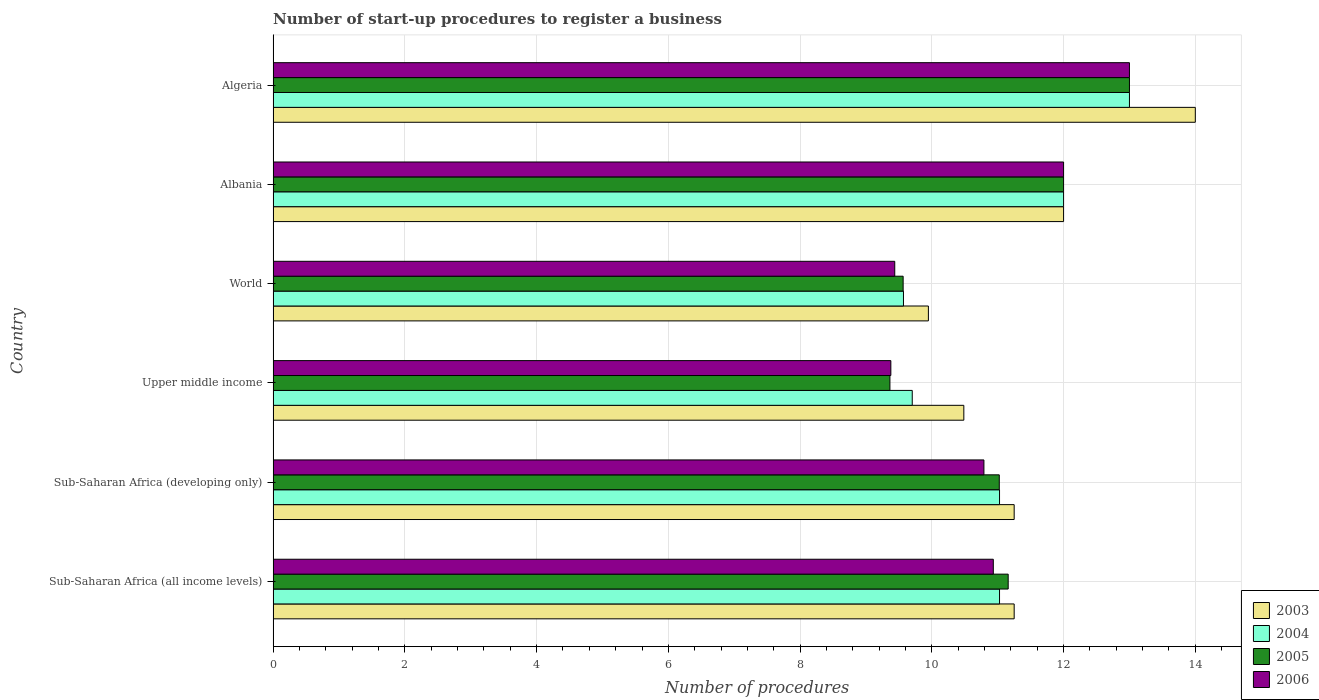How many different coloured bars are there?
Your answer should be compact. 4. Are the number of bars per tick equal to the number of legend labels?
Provide a short and direct response. Yes. How many bars are there on the 2nd tick from the top?
Your answer should be very brief. 4. What is the label of the 2nd group of bars from the top?
Ensure brevity in your answer.  Albania. In how many cases, is the number of bars for a given country not equal to the number of legend labels?
Make the answer very short. 0. What is the number of procedures required to register a business in 2005 in Upper middle income?
Offer a terse response. 9.36. Across all countries, what is the maximum number of procedures required to register a business in 2003?
Your answer should be very brief. 14. Across all countries, what is the minimum number of procedures required to register a business in 2005?
Provide a succinct answer. 9.36. In which country was the number of procedures required to register a business in 2004 maximum?
Keep it short and to the point. Algeria. In which country was the number of procedures required to register a business in 2004 minimum?
Ensure brevity in your answer.  World. What is the total number of procedures required to register a business in 2006 in the graph?
Provide a succinct answer. 65.54. What is the difference between the number of procedures required to register a business in 2004 in Albania and that in World?
Your response must be concise. 2.43. What is the difference between the number of procedures required to register a business in 2005 in Sub-Saharan Africa (all income levels) and the number of procedures required to register a business in 2006 in Algeria?
Keep it short and to the point. -1.84. What is the average number of procedures required to register a business in 2003 per country?
Your response must be concise. 11.49. What is the difference between the number of procedures required to register a business in 2003 and number of procedures required to register a business in 2005 in Sub-Saharan Africa (developing only)?
Ensure brevity in your answer.  0.23. What is the ratio of the number of procedures required to register a business in 2004 in Algeria to that in Sub-Saharan Africa (all income levels)?
Offer a very short reply. 1.18. Is the number of procedures required to register a business in 2006 in Sub-Saharan Africa (all income levels) less than that in Upper middle income?
Provide a short and direct response. No. What is the difference between the highest and the lowest number of procedures required to register a business in 2005?
Offer a very short reply. 3.64. In how many countries, is the number of procedures required to register a business in 2004 greater than the average number of procedures required to register a business in 2004 taken over all countries?
Provide a short and direct response. 2. Is the sum of the number of procedures required to register a business in 2005 in Albania and Upper middle income greater than the maximum number of procedures required to register a business in 2006 across all countries?
Your answer should be very brief. Yes. What does the 2nd bar from the bottom in Albania represents?
Your response must be concise. 2004. Are all the bars in the graph horizontal?
Ensure brevity in your answer.  Yes. How many countries are there in the graph?
Ensure brevity in your answer.  6. What is the difference between two consecutive major ticks on the X-axis?
Your response must be concise. 2. Are the values on the major ticks of X-axis written in scientific E-notation?
Give a very brief answer. No. Does the graph contain any zero values?
Your answer should be compact. No. What is the title of the graph?
Offer a very short reply. Number of start-up procedures to register a business. Does "1989" appear as one of the legend labels in the graph?
Offer a terse response. No. What is the label or title of the X-axis?
Offer a very short reply. Number of procedures. What is the label or title of the Y-axis?
Provide a short and direct response. Country. What is the Number of procedures in 2003 in Sub-Saharan Africa (all income levels)?
Give a very brief answer. 11.25. What is the Number of procedures of 2004 in Sub-Saharan Africa (all income levels)?
Your answer should be very brief. 11.03. What is the Number of procedures in 2005 in Sub-Saharan Africa (all income levels)?
Make the answer very short. 11.16. What is the Number of procedures in 2006 in Sub-Saharan Africa (all income levels)?
Offer a very short reply. 10.93. What is the Number of procedures of 2003 in Sub-Saharan Africa (developing only)?
Provide a short and direct response. 11.25. What is the Number of procedures in 2004 in Sub-Saharan Africa (developing only)?
Ensure brevity in your answer.  11.03. What is the Number of procedures in 2005 in Sub-Saharan Africa (developing only)?
Your response must be concise. 11.02. What is the Number of procedures in 2006 in Sub-Saharan Africa (developing only)?
Your response must be concise. 10.79. What is the Number of procedures in 2003 in Upper middle income?
Your answer should be compact. 10.49. What is the Number of procedures of 2004 in Upper middle income?
Ensure brevity in your answer.  9.7. What is the Number of procedures of 2005 in Upper middle income?
Your response must be concise. 9.36. What is the Number of procedures of 2006 in Upper middle income?
Offer a terse response. 9.38. What is the Number of procedures in 2003 in World?
Offer a terse response. 9.95. What is the Number of procedures of 2004 in World?
Ensure brevity in your answer.  9.57. What is the Number of procedures in 2005 in World?
Your answer should be very brief. 9.56. What is the Number of procedures in 2006 in World?
Offer a very short reply. 9.44. What is the Number of procedures in 2003 in Albania?
Offer a terse response. 12. What is the Number of procedures of 2004 in Albania?
Your response must be concise. 12. What is the Number of procedures in 2006 in Albania?
Provide a short and direct response. 12. Across all countries, what is the maximum Number of procedures of 2003?
Offer a very short reply. 14. Across all countries, what is the maximum Number of procedures of 2006?
Provide a short and direct response. 13. Across all countries, what is the minimum Number of procedures of 2003?
Your answer should be very brief. 9.95. Across all countries, what is the minimum Number of procedures in 2004?
Offer a terse response. 9.57. Across all countries, what is the minimum Number of procedures in 2005?
Your response must be concise. 9.36. Across all countries, what is the minimum Number of procedures of 2006?
Your answer should be compact. 9.38. What is the total Number of procedures in 2003 in the graph?
Your answer should be compact. 68.93. What is the total Number of procedures in 2004 in the graph?
Give a very brief answer. 66.33. What is the total Number of procedures in 2005 in the graph?
Offer a very short reply. 66.11. What is the total Number of procedures in 2006 in the graph?
Make the answer very short. 65.54. What is the difference between the Number of procedures of 2005 in Sub-Saharan Africa (all income levels) and that in Sub-Saharan Africa (developing only)?
Your response must be concise. 0.14. What is the difference between the Number of procedures of 2006 in Sub-Saharan Africa (all income levels) and that in Sub-Saharan Africa (developing only)?
Your response must be concise. 0.14. What is the difference between the Number of procedures of 2003 in Sub-Saharan Africa (all income levels) and that in Upper middle income?
Provide a succinct answer. 0.76. What is the difference between the Number of procedures in 2004 in Sub-Saharan Africa (all income levels) and that in Upper middle income?
Offer a terse response. 1.33. What is the difference between the Number of procedures in 2005 in Sub-Saharan Africa (all income levels) and that in Upper middle income?
Provide a short and direct response. 1.8. What is the difference between the Number of procedures of 2006 in Sub-Saharan Africa (all income levels) and that in Upper middle income?
Offer a very short reply. 1.56. What is the difference between the Number of procedures of 2003 in Sub-Saharan Africa (all income levels) and that in World?
Ensure brevity in your answer.  1.3. What is the difference between the Number of procedures in 2004 in Sub-Saharan Africa (all income levels) and that in World?
Give a very brief answer. 1.46. What is the difference between the Number of procedures in 2005 in Sub-Saharan Africa (all income levels) and that in World?
Make the answer very short. 1.59. What is the difference between the Number of procedures in 2006 in Sub-Saharan Africa (all income levels) and that in World?
Provide a short and direct response. 1.5. What is the difference between the Number of procedures of 2003 in Sub-Saharan Africa (all income levels) and that in Albania?
Give a very brief answer. -0.75. What is the difference between the Number of procedures of 2004 in Sub-Saharan Africa (all income levels) and that in Albania?
Offer a very short reply. -0.97. What is the difference between the Number of procedures of 2005 in Sub-Saharan Africa (all income levels) and that in Albania?
Offer a terse response. -0.84. What is the difference between the Number of procedures of 2006 in Sub-Saharan Africa (all income levels) and that in Albania?
Offer a very short reply. -1.07. What is the difference between the Number of procedures in 2003 in Sub-Saharan Africa (all income levels) and that in Algeria?
Offer a very short reply. -2.75. What is the difference between the Number of procedures in 2004 in Sub-Saharan Africa (all income levels) and that in Algeria?
Keep it short and to the point. -1.97. What is the difference between the Number of procedures in 2005 in Sub-Saharan Africa (all income levels) and that in Algeria?
Provide a short and direct response. -1.84. What is the difference between the Number of procedures of 2006 in Sub-Saharan Africa (all income levels) and that in Algeria?
Offer a very short reply. -2.07. What is the difference between the Number of procedures in 2003 in Sub-Saharan Africa (developing only) and that in Upper middle income?
Keep it short and to the point. 0.76. What is the difference between the Number of procedures in 2004 in Sub-Saharan Africa (developing only) and that in Upper middle income?
Your response must be concise. 1.33. What is the difference between the Number of procedures of 2005 in Sub-Saharan Africa (developing only) and that in Upper middle income?
Offer a very short reply. 1.66. What is the difference between the Number of procedures of 2006 in Sub-Saharan Africa (developing only) and that in Upper middle income?
Your answer should be compact. 1.41. What is the difference between the Number of procedures in 2003 in Sub-Saharan Africa (developing only) and that in World?
Provide a succinct answer. 1.3. What is the difference between the Number of procedures in 2004 in Sub-Saharan Africa (developing only) and that in World?
Keep it short and to the point. 1.46. What is the difference between the Number of procedures of 2005 in Sub-Saharan Africa (developing only) and that in World?
Your answer should be very brief. 1.46. What is the difference between the Number of procedures in 2006 in Sub-Saharan Africa (developing only) and that in World?
Offer a very short reply. 1.35. What is the difference between the Number of procedures in 2003 in Sub-Saharan Africa (developing only) and that in Albania?
Provide a short and direct response. -0.75. What is the difference between the Number of procedures in 2004 in Sub-Saharan Africa (developing only) and that in Albania?
Provide a succinct answer. -0.97. What is the difference between the Number of procedures in 2005 in Sub-Saharan Africa (developing only) and that in Albania?
Your response must be concise. -0.98. What is the difference between the Number of procedures in 2006 in Sub-Saharan Africa (developing only) and that in Albania?
Keep it short and to the point. -1.21. What is the difference between the Number of procedures in 2003 in Sub-Saharan Africa (developing only) and that in Algeria?
Your response must be concise. -2.75. What is the difference between the Number of procedures in 2004 in Sub-Saharan Africa (developing only) and that in Algeria?
Ensure brevity in your answer.  -1.97. What is the difference between the Number of procedures in 2005 in Sub-Saharan Africa (developing only) and that in Algeria?
Your response must be concise. -1.98. What is the difference between the Number of procedures of 2006 in Sub-Saharan Africa (developing only) and that in Algeria?
Your answer should be compact. -2.21. What is the difference between the Number of procedures of 2003 in Upper middle income and that in World?
Keep it short and to the point. 0.54. What is the difference between the Number of procedures in 2004 in Upper middle income and that in World?
Keep it short and to the point. 0.13. What is the difference between the Number of procedures of 2005 in Upper middle income and that in World?
Ensure brevity in your answer.  -0.2. What is the difference between the Number of procedures in 2006 in Upper middle income and that in World?
Your answer should be very brief. -0.06. What is the difference between the Number of procedures in 2003 in Upper middle income and that in Albania?
Make the answer very short. -1.51. What is the difference between the Number of procedures in 2004 in Upper middle income and that in Albania?
Your response must be concise. -2.3. What is the difference between the Number of procedures in 2005 in Upper middle income and that in Albania?
Provide a succinct answer. -2.64. What is the difference between the Number of procedures of 2006 in Upper middle income and that in Albania?
Provide a short and direct response. -2.62. What is the difference between the Number of procedures in 2003 in Upper middle income and that in Algeria?
Provide a succinct answer. -3.51. What is the difference between the Number of procedures of 2004 in Upper middle income and that in Algeria?
Provide a short and direct response. -3.3. What is the difference between the Number of procedures of 2005 in Upper middle income and that in Algeria?
Offer a very short reply. -3.64. What is the difference between the Number of procedures of 2006 in Upper middle income and that in Algeria?
Make the answer very short. -3.62. What is the difference between the Number of procedures in 2003 in World and that in Albania?
Offer a terse response. -2.05. What is the difference between the Number of procedures in 2004 in World and that in Albania?
Keep it short and to the point. -2.43. What is the difference between the Number of procedures in 2005 in World and that in Albania?
Provide a short and direct response. -2.44. What is the difference between the Number of procedures of 2006 in World and that in Albania?
Your response must be concise. -2.56. What is the difference between the Number of procedures in 2003 in World and that in Algeria?
Offer a terse response. -4.05. What is the difference between the Number of procedures of 2004 in World and that in Algeria?
Your response must be concise. -3.43. What is the difference between the Number of procedures of 2005 in World and that in Algeria?
Give a very brief answer. -3.44. What is the difference between the Number of procedures in 2006 in World and that in Algeria?
Offer a terse response. -3.56. What is the difference between the Number of procedures of 2005 in Albania and that in Algeria?
Give a very brief answer. -1. What is the difference between the Number of procedures in 2003 in Sub-Saharan Africa (all income levels) and the Number of procedures in 2004 in Sub-Saharan Africa (developing only)?
Offer a terse response. 0.22. What is the difference between the Number of procedures in 2003 in Sub-Saharan Africa (all income levels) and the Number of procedures in 2005 in Sub-Saharan Africa (developing only)?
Ensure brevity in your answer.  0.23. What is the difference between the Number of procedures in 2003 in Sub-Saharan Africa (all income levels) and the Number of procedures in 2006 in Sub-Saharan Africa (developing only)?
Keep it short and to the point. 0.46. What is the difference between the Number of procedures of 2004 in Sub-Saharan Africa (all income levels) and the Number of procedures of 2005 in Sub-Saharan Africa (developing only)?
Provide a succinct answer. 0. What is the difference between the Number of procedures of 2004 in Sub-Saharan Africa (all income levels) and the Number of procedures of 2006 in Sub-Saharan Africa (developing only)?
Give a very brief answer. 0.24. What is the difference between the Number of procedures in 2005 in Sub-Saharan Africa (all income levels) and the Number of procedures in 2006 in Sub-Saharan Africa (developing only)?
Provide a short and direct response. 0.37. What is the difference between the Number of procedures of 2003 in Sub-Saharan Africa (all income levels) and the Number of procedures of 2004 in Upper middle income?
Offer a very short reply. 1.55. What is the difference between the Number of procedures of 2003 in Sub-Saharan Africa (all income levels) and the Number of procedures of 2005 in Upper middle income?
Provide a short and direct response. 1.89. What is the difference between the Number of procedures in 2003 in Sub-Saharan Africa (all income levels) and the Number of procedures in 2006 in Upper middle income?
Provide a short and direct response. 1.87. What is the difference between the Number of procedures in 2004 in Sub-Saharan Africa (all income levels) and the Number of procedures in 2005 in Upper middle income?
Offer a terse response. 1.66. What is the difference between the Number of procedures in 2004 in Sub-Saharan Africa (all income levels) and the Number of procedures in 2006 in Upper middle income?
Provide a short and direct response. 1.65. What is the difference between the Number of procedures of 2005 in Sub-Saharan Africa (all income levels) and the Number of procedures of 2006 in Upper middle income?
Give a very brief answer. 1.78. What is the difference between the Number of procedures in 2003 in Sub-Saharan Africa (all income levels) and the Number of procedures in 2004 in World?
Offer a very short reply. 1.68. What is the difference between the Number of procedures in 2003 in Sub-Saharan Africa (all income levels) and the Number of procedures in 2005 in World?
Give a very brief answer. 1.69. What is the difference between the Number of procedures in 2003 in Sub-Saharan Africa (all income levels) and the Number of procedures in 2006 in World?
Keep it short and to the point. 1.81. What is the difference between the Number of procedures in 2004 in Sub-Saharan Africa (all income levels) and the Number of procedures in 2005 in World?
Provide a succinct answer. 1.46. What is the difference between the Number of procedures in 2004 in Sub-Saharan Africa (all income levels) and the Number of procedures in 2006 in World?
Your answer should be compact. 1.59. What is the difference between the Number of procedures of 2005 in Sub-Saharan Africa (all income levels) and the Number of procedures of 2006 in World?
Give a very brief answer. 1.72. What is the difference between the Number of procedures in 2003 in Sub-Saharan Africa (all income levels) and the Number of procedures in 2004 in Albania?
Make the answer very short. -0.75. What is the difference between the Number of procedures of 2003 in Sub-Saharan Africa (all income levels) and the Number of procedures of 2005 in Albania?
Provide a succinct answer. -0.75. What is the difference between the Number of procedures in 2003 in Sub-Saharan Africa (all income levels) and the Number of procedures in 2006 in Albania?
Your answer should be compact. -0.75. What is the difference between the Number of procedures in 2004 in Sub-Saharan Africa (all income levels) and the Number of procedures in 2005 in Albania?
Your response must be concise. -0.97. What is the difference between the Number of procedures of 2004 in Sub-Saharan Africa (all income levels) and the Number of procedures of 2006 in Albania?
Give a very brief answer. -0.97. What is the difference between the Number of procedures of 2005 in Sub-Saharan Africa (all income levels) and the Number of procedures of 2006 in Albania?
Provide a succinct answer. -0.84. What is the difference between the Number of procedures of 2003 in Sub-Saharan Africa (all income levels) and the Number of procedures of 2004 in Algeria?
Offer a very short reply. -1.75. What is the difference between the Number of procedures in 2003 in Sub-Saharan Africa (all income levels) and the Number of procedures in 2005 in Algeria?
Provide a succinct answer. -1.75. What is the difference between the Number of procedures of 2003 in Sub-Saharan Africa (all income levels) and the Number of procedures of 2006 in Algeria?
Ensure brevity in your answer.  -1.75. What is the difference between the Number of procedures of 2004 in Sub-Saharan Africa (all income levels) and the Number of procedures of 2005 in Algeria?
Give a very brief answer. -1.97. What is the difference between the Number of procedures in 2004 in Sub-Saharan Africa (all income levels) and the Number of procedures in 2006 in Algeria?
Make the answer very short. -1.97. What is the difference between the Number of procedures of 2005 in Sub-Saharan Africa (all income levels) and the Number of procedures of 2006 in Algeria?
Your answer should be very brief. -1.84. What is the difference between the Number of procedures in 2003 in Sub-Saharan Africa (developing only) and the Number of procedures in 2004 in Upper middle income?
Offer a terse response. 1.55. What is the difference between the Number of procedures in 2003 in Sub-Saharan Africa (developing only) and the Number of procedures in 2005 in Upper middle income?
Offer a very short reply. 1.89. What is the difference between the Number of procedures of 2003 in Sub-Saharan Africa (developing only) and the Number of procedures of 2006 in Upper middle income?
Provide a succinct answer. 1.87. What is the difference between the Number of procedures of 2004 in Sub-Saharan Africa (developing only) and the Number of procedures of 2005 in Upper middle income?
Offer a very short reply. 1.66. What is the difference between the Number of procedures in 2004 in Sub-Saharan Africa (developing only) and the Number of procedures in 2006 in Upper middle income?
Your response must be concise. 1.65. What is the difference between the Number of procedures in 2005 in Sub-Saharan Africa (developing only) and the Number of procedures in 2006 in Upper middle income?
Ensure brevity in your answer.  1.65. What is the difference between the Number of procedures of 2003 in Sub-Saharan Africa (developing only) and the Number of procedures of 2004 in World?
Ensure brevity in your answer.  1.68. What is the difference between the Number of procedures of 2003 in Sub-Saharan Africa (developing only) and the Number of procedures of 2005 in World?
Your answer should be very brief. 1.69. What is the difference between the Number of procedures in 2003 in Sub-Saharan Africa (developing only) and the Number of procedures in 2006 in World?
Offer a very short reply. 1.81. What is the difference between the Number of procedures in 2004 in Sub-Saharan Africa (developing only) and the Number of procedures in 2005 in World?
Keep it short and to the point. 1.46. What is the difference between the Number of procedures of 2004 in Sub-Saharan Africa (developing only) and the Number of procedures of 2006 in World?
Your response must be concise. 1.59. What is the difference between the Number of procedures of 2005 in Sub-Saharan Africa (developing only) and the Number of procedures of 2006 in World?
Provide a succinct answer. 1.59. What is the difference between the Number of procedures of 2003 in Sub-Saharan Africa (developing only) and the Number of procedures of 2004 in Albania?
Provide a succinct answer. -0.75. What is the difference between the Number of procedures in 2003 in Sub-Saharan Africa (developing only) and the Number of procedures in 2005 in Albania?
Your answer should be very brief. -0.75. What is the difference between the Number of procedures in 2003 in Sub-Saharan Africa (developing only) and the Number of procedures in 2006 in Albania?
Your answer should be compact. -0.75. What is the difference between the Number of procedures in 2004 in Sub-Saharan Africa (developing only) and the Number of procedures in 2005 in Albania?
Offer a very short reply. -0.97. What is the difference between the Number of procedures in 2004 in Sub-Saharan Africa (developing only) and the Number of procedures in 2006 in Albania?
Your answer should be compact. -0.97. What is the difference between the Number of procedures of 2005 in Sub-Saharan Africa (developing only) and the Number of procedures of 2006 in Albania?
Keep it short and to the point. -0.98. What is the difference between the Number of procedures of 2003 in Sub-Saharan Africa (developing only) and the Number of procedures of 2004 in Algeria?
Provide a succinct answer. -1.75. What is the difference between the Number of procedures in 2003 in Sub-Saharan Africa (developing only) and the Number of procedures in 2005 in Algeria?
Keep it short and to the point. -1.75. What is the difference between the Number of procedures of 2003 in Sub-Saharan Africa (developing only) and the Number of procedures of 2006 in Algeria?
Your answer should be very brief. -1.75. What is the difference between the Number of procedures in 2004 in Sub-Saharan Africa (developing only) and the Number of procedures in 2005 in Algeria?
Your answer should be very brief. -1.97. What is the difference between the Number of procedures in 2004 in Sub-Saharan Africa (developing only) and the Number of procedures in 2006 in Algeria?
Offer a terse response. -1.97. What is the difference between the Number of procedures in 2005 in Sub-Saharan Africa (developing only) and the Number of procedures in 2006 in Algeria?
Offer a very short reply. -1.98. What is the difference between the Number of procedures of 2003 in Upper middle income and the Number of procedures of 2004 in World?
Your response must be concise. 0.92. What is the difference between the Number of procedures of 2003 in Upper middle income and the Number of procedures of 2005 in World?
Your response must be concise. 0.92. What is the difference between the Number of procedures in 2003 in Upper middle income and the Number of procedures in 2006 in World?
Keep it short and to the point. 1.05. What is the difference between the Number of procedures of 2004 in Upper middle income and the Number of procedures of 2005 in World?
Make the answer very short. 0.14. What is the difference between the Number of procedures in 2004 in Upper middle income and the Number of procedures in 2006 in World?
Offer a very short reply. 0.27. What is the difference between the Number of procedures of 2005 in Upper middle income and the Number of procedures of 2006 in World?
Provide a short and direct response. -0.07. What is the difference between the Number of procedures of 2003 in Upper middle income and the Number of procedures of 2004 in Albania?
Make the answer very short. -1.51. What is the difference between the Number of procedures in 2003 in Upper middle income and the Number of procedures in 2005 in Albania?
Your response must be concise. -1.51. What is the difference between the Number of procedures of 2003 in Upper middle income and the Number of procedures of 2006 in Albania?
Offer a very short reply. -1.51. What is the difference between the Number of procedures in 2004 in Upper middle income and the Number of procedures in 2005 in Albania?
Your answer should be compact. -2.3. What is the difference between the Number of procedures of 2004 in Upper middle income and the Number of procedures of 2006 in Albania?
Your answer should be very brief. -2.3. What is the difference between the Number of procedures in 2005 in Upper middle income and the Number of procedures in 2006 in Albania?
Your answer should be compact. -2.64. What is the difference between the Number of procedures in 2003 in Upper middle income and the Number of procedures in 2004 in Algeria?
Provide a succinct answer. -2.51. What is the difference between the Number of procedures of 2003 in Upper middle income and the Number of procedures of 2005 in Algeria?
Keep it short and to the point. -2.51. What is the difference between the Number of procedures in 2003 in Upper middle income and the Number of procedures in 2006 in Algeria?
Provide a short and direct response. -2.51. What is the difference between the Number of procedures in 2004 in Upper middle income and the Number of procedures in 2005 in Algeria?
Your response must be concise. -3.3. What is the difference between the Number of procedures of 2004 in Upper middle income and the Number of procedures of 2006 in Algeria?
Provide a short and direct response. -3.3. What is the difference between the Number of procedures of 2005 in Upper middle income and the Number of procedures of 2006 in Algeria?
Provide a short and direct response. -3.64. What is the difference between the Number of procedures in 2003 in World and the Number of procedures in 2004 in Albania?
Make the answer very short. -2.05. What is the difference between the Number of procedures in 2003 in World and the Number of procedures in 2005 in Albania?
Your response must be concise. -2.05. What is the difference between the Number of procedures of 2003 in World and the Number of procedures of 2006 in Albania?
Your answer should be compact. -2.05. What is the difference between the Number of procedures in 2004 in World and the Number of procedures in 2005 in Albania?
Your answer should be compact. -2.43. What is the difference between the Number of procedures of 2004 in World and the Number of procedures of 2006 in Albania?
Offer a terse response. -2.43. What is the difference between the Number of procedures of 2005 in World and the Number of procedures of 2006 in Albania?
Provide a succinct answer. -2.44. What is the difference between the Number of procedures in 2003 in World and the Number of procedures in 2004 in Algeria?
Your response must be concise. -3.05. What is the difference between the Number of procedures of 2003 in World and the Number of procedures of 2005 in Algeria?
Your answer should be compact. -3.05. What is the difference between the Number of procedures of 2003 in World and the Number of procedures of 2006 in Algeria?
Offer a terse response. -3.05. What is the difference between the Number of procedures of 2004 in World and the Number of procedures of 2005 in Algeria?
Offer a very short reply. -3.43. What is the difference between the Number of procedures in 2004 in World and the Number of procedures in 2006 in Algeria?
Give a very brief answer. -3.43. What is the difference between the Number of procedures in 2005 in World and the Number of procedures in 2006 in Algeria?
Keep it short and to the point. -3.44. What is the difference between the Number of procedures in 2003 in Albania and the Number of procedures in 2004 in Algeria?
Make the answer very short. -1. What is the difference between the Number of procedures in 2003 in Albania and the Number of procedures in 2006 in Algeria?
Provide a succinct answer. -1. What is the difference between the Number of procedures of 2005 in Albania and the Number of procedures of 2006 in Algeria?
Ensure brevity in your answer.  -1. What is the average Number of procedures of 2003 per country?
Make the answer very short. 11.49. What is the average Number of procedures of 2004 per country?
Provide a succinct answer. 11.05. What is the average Number of procedures of 2005 per country?
Ensure brevity in your answer.  11.02. What is the average Number of procedures in 2006 per country?
Give a very brief answer. 10.92. What is the difference between the Number of procedures of 2003 and Number of procedures of 2004 in Sub-Saharan Africa (all income levels)?
Provide a short and direct response. 0.22. What is the difference between the Number of procedures in 2003 and Number of procedures in 2005 in Sub-Saharan Africa (all income levels)?
Provide a short and direct response. 0.09. What is the difference between the Number of procedures in 2003 and Number of procedures in 2006 in Sub-Saharan Africa (all income levels)?
Provide a succinct answer. 0.32. What is the difference between the Number of procedures of 2004 and Number of procedures of 2005 in Sub-Saharan Africa (all income levels)?
Make the answer very short. -0.13. What is the difference between the Number of procedures of 2004 and Number of procedures of 2006 in Sub-Saharan Africa (all income levels)?
Make the answer very short. 0.09. What is the difference between the Number of procedures of 2005 and Number of procedures of 2006 in Sub-Saharan Africa (all income levels)?
Give a very brief answer. 0.23. What is the difference between the Number of procedures of 2003 and Number of procedures of 2004 in Sub-Saharan Africa (developing only)?
Provide a short and direct response. 0.22. What is the difference between the Number of procedures of 2003 and Number of procedures of 2005 in Sub-Saharan Africa (developing only)?
Your response must be concise. 0.23. What is the difference between the Number of procedures of 2003 and Number of procedures of 2006 in Sub-Saharan Africa (developing only)?
Give a very brief answer. 0.46. What is the difference between the Number of procedures of 2004 and Number of procedures of 2005 in Sub-Saharan Africa (developing only)?
Keep it short and to the point. 0. What is the difference between the Number of procedures of 2004 and Number of procedures of 2006 in Sub-Saharan Africa (developing only)?
Provide a short and direct response. 0.24. What is the difference between the Number of procedures of 2005 and Number of procedures of 2006 in Sub-Saharan Africa (developing only)?
Provide a short and direct response. 0.23. What is the difference between the Number of procedures of 2003 and Number of procedures of 2004 in Upper middle income?
Your response must be concise. 0.78. What is the difference between the Number of procedures in 2003 and Number of procedures in 2005 in Upper middle income?
Offer a very short reply. 1.12. What is the difference between the Number of procedures in 2003 and Number of procedures in 2006 in Upper middle income?
Make the answer very short. 1.11. What is the difference between the Number of procedures of 2004 and Number of procedures of 2005 in Upper middle income?
Your response must be concise. 0.34. What is the difference between the Number of procedures in 2004 and Number of procedures in 2006 in Upper middle income?
Keep it short and to the point. 0.32. What is the difference between the Number of procedures of 2005 and Number of procedures of 2006 in Upper middle income?
Your response must be concise. -0.01. What is the difference between the Number of procedures in 2003 and Number of procedures in 2004 in World?
Your response must be concise. 0.38. What is the difference between the Number of procedures of 2003 and Number of procedures of 2005 in World?
Provide a succinct answer. 0.38. What is the difference between the Number of procedures of 2003 and Number of procedures of 2006 in World?
Your answer should be very brief. 0.51. What is the difference between the Number of procedures of 2004 and Number of procedures of 2005 in World?
Keep it short and to the point. 0.01. What is the difference between the Number of procedures in 2004 and Number of procedures in 2006 in World?
Offer a very short reply. 0.13. What is the difference between the Number of procedures of 2005 and Number of procedures of 2006 in World?
Provide a short and direct response. 0.13. What is the difference between the Number of procedures of 2005 and Number of procedures of 2006 in Albania?
Ensure brevity in your answer.  0. What is the difference between the Number of procedures of 2003 and Number of procedures of 2006 in Algeria?
Keep it short and to the point. 1. What is the ratio of the Number of procedures of 2003 in Sub-Saharan Africa (all income levels) to that in Sub-Saharan Africa (developing only)?
Give a very brief answer. 1. What is the ratio of the Number of procedures in 2005 in Sub-Saharan Africa (all income levels) to that in Sub-Saharan Africa (developing only)?
Keep it short and to the point. 1.01. What is the ratio of the Number of procedures in 2006 in Sub-Saharan Africa (all income levels) to that in Sub-Saharan Africa (developing only)?
Ensure brevity in your answer.  1.01. What is the ratio of the Number of procedures in 2003 in Sub-Saharan Africa (all income levels) to that in Upper middle income?
Give a very brief answer. 1.07. What is the ratio of the Number of procedures in 2004 in Sub-Saharan Africa (all income levels) to that in Upper middle income?
Make the answer very short. 1.14. What is the ratio of the Number of procedures in 2005 in Sub-Saharan Africa (all income levels) to that in Upper middle income?
Your answer should be very brief. 1.19. What is the ratio of the Number of procedures of 2006 in Sub-Saharan Africa (all income levels) to that in Upper middle income?
Ensure brevity in your answer.  1.17. What is the ratio of the Number of procedures in 2003 in Sub-Saharan Africa (all income levels) to that in World?
Offer a very short reply. 1.13. What is the ratio of the Number of procedures in 2004 in Sub-Saharan Africa (all income levels) to that in World?
Your answer should be compact. 1.15. What is the ratio of the Number of procedures of 2005 in Sub-Saharan Africa (all income levels) to that in World?
Give a very brief answer. 1.17. What is the ratio of the Number of procedures of 2006 in Sub-Saharan Africa (all income levels) to that in World?
Your answer should be very brief. 1.16. What is the ratio of the Number of procedures of 2004 in Sub-Saharan Africa (all income levels) to that in Albania?
Your response must be concise. 0.92. What is the ratio of the Number of procedures of 2005 in Sub-Saharan Africa (all income levels) to that in Albania?
Offer a terse response. 0.93. What is the ratio of the Number of procedures of 2006 in Sub-Saharan Africa (all income levels) to that in Albania?
Offer a very short reply. 0.91. What is the ratio of the Number of procedures of 2003 in Sub-Saharan Africa (all income levels) to that in Algeria?
Keep it short and to the point. 0.8. What is the ratio of the Number of procedures of 2004 in Sub-Saharan Africa (all income levels) to that in Algeria?
Keep it short and to the point. 0.85. What is the ratio of the Number of procedures of 2005 in Sub-Saharan Africa (all income levels) to that in Algeria?
Your response must be concise. 0.86. What is the ratio of the Number of procedures of 2006 in Sub-Saharan Africa (all income levels) to that in Algeria?
Offer a terse response. 0.84. What is the ratio of the Number of procedures of 2003 in Sub-Saharan Africa (developing only) to that in Upper middle income?
Keep it short and to the point. 1.07. What is the ratio of the Number of procedures in 2004 in Sub-Saharan Africa (developing only) to that in Upper middle income?
Give a very brief answer. 1.14. What is the ratio of the Number of procedures in 2005 in Sub-Saharan Africa (developing only) to that in Upper middle income?
Keep it short and to the point. 1.18. What is the ratio of the Number of procedures in 2006 in Sub-Saharan Africa (developing only) to that in Upper middle income?
Your answer should be compact. 1.15. What is the ratio of the Number of procedures of 2003 in Sub-Saharan Africa (developing only) to that in World?
Offer a very short reply. 1.13. What is the ratio of the Number of procedures in 2004 in Sub-Saharan Africa (developing only) to that in World?
Your answer should be very brief. 1.15. What is the ratio of the Number of procedures in 2005 in Sub-Saharan Africa (developing only) to that in World?
Keep it short and to the point. 1.15. What is the ratio of the Number of procedures of 2006 in Sub-Saharan Africa (developing only) to that in World?
Give a very brief answer. 1.14. What is the ratio of the Number of procedures of 2004 in Sub-Saharan Africa (developing only) to that in Albania?
Ensure brevity in your answer.  0.92. What is the ratio of the Number of procedures of 2005 in Sub-Saharan Africa (developing only) to that in Albania?
Your response must be concise. 0.92. What is the ratio of the Number of procedures of 2006 in Sub-Saharan Africa (developing only) to that in Albania?
Offer a very short reply. 0.9. What is the ratio of the Number of procedures in 2003 in Sub-Saharan Africa (developing only) to that in Algeria?
Provide a succinct answer. 0.8. What is the ratio of the Number of procedures in 2004 in Sub-Saharan Africa (developing only) to that in Algeria?
Keep it short and to the point. 0.85. What is the ratio of the Number of procedures in 2005 in Sub-Saharan Africa (developing only) to that in Algeria?
Offer a terse response. 0.85. What is the ratio of the Number of procedures in 2006 in Sub-Saharan Africa (developing only) to that in Algeria?
Offer a very short reply. 0.83. What is the ratio of the Number of procedures of 2003 in Upper middle income to that in World?
Keep it short and to the point. 1.05. What is the ratio of the Number of procedures in 2004 in Upper middle income to that in World?
Provide a short and direct response. 1.01. What is the ratio of the Number of procedures in 2005 in Upper middle income to that in World?
Your response must be concise. 0.98. What is the ratio of the Number of procedures in 2006 in Upper middle income to that in World?
Provide a succinct answer. 0.99. What is the ratio of the Number of procedures in 2003 in Upper middle income to that in Albania?
Ensure brevity in your answer.  0.87. What is the ratio of the Number of procedures in 2004 in Upper middle income to that in Albania?
Provide a short and direct response. 0.81. What is the ratio of the Number of procedures in 2005 in Upper middle income to that in Albania?
Make the answer very short. 0.78. What is the ratio of the Number of procedures of 2006 in Upper middle income to that in Albania?
Your response must be concise. 0.78. What is the ratio of the Number of procedures of 2003 in Upper middle income to that in Algeria?
Your response must be concise. 0.75. What is the ratio of the Number of procedures of 2004 in Upper middle income to that in Algeria?
Keep it short and to the point. 0.75. What is the ratio of the Number of procedures of 2005 in Upper middle income to that in Algeria?
Keep it short and to the point. 0.72. What is the ratio of the Number of procedures of 2006 in Upper middle income to that in Algeria?
Keep it short and to the point. 0.72. What is the ratio of the Number of procedures in 2003 in World to that in Albania?
Offer a very short reply. 0.83. What is the ratio of the Number of procedures in 2004 in World to that in Albania?
Your response must be concise. 0.8. What is the ratio of the Number of procedures of 2005 in World to that in Albania?
Ensure brevity in your answer.  0.8. What is the ratio of the Number of procedures in 2006 in World to that in Albania?
Keep it short and to the point. 0.79. What is the ratio of the Number of procedures of 2003 in World to that in Algeria?
Offer a very short reply. 0.71. What is the ratio of the Number of procedures in 2004 in World to that in Algeria?
Your response must be concise. 0.74. What is the ratio of the Number of procedures in 2005 in World to that in Algeria?
Your response must be concise. 0.74. What is the ratio of the Number of procedures of 2006 in World to that in Algeria?
Make the answer very short. 0.73. What is the ratio of the Number of procedures in 2005 in Albania to that in Algeria?
Your answer should be compact. 0.92. What is the ratio of the Number of procedures in 2006 in Albania to that in Algeria?
Offer a very short reply. 0.92. What is the difference between the highest and the second highest Number of procedures in 2003?
Offer a terse response. 2. What is the difference between the highest and the second highest Number of procedures of 2004?
Ensure brevity in your answer.  1. What is the difference between the highest and the second highest Number of procedures in 2006?
Your response must be concise. 1. What is the difference between the highest and the lowest Number of procedures of 2003?
Give a very brief answer. 4.05. What is the difference between the highest and the lowest Number of procedures in 2004?
Your answer should be compact. 3.43. What is the difference between the highest and the lowest Number of procedures in 2005?
Keep it short and to the point. 3.64. What is the difference between the highest and the lowest Number of procedures of 2006?
Offer a very short reply. 3.62. 